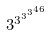<formula> <loc_0><loc_0><loc_500><loc_500>3 ^ { 3 ^ { 3 ^ { 3 ^ { 4 6 } } } }</formula> 